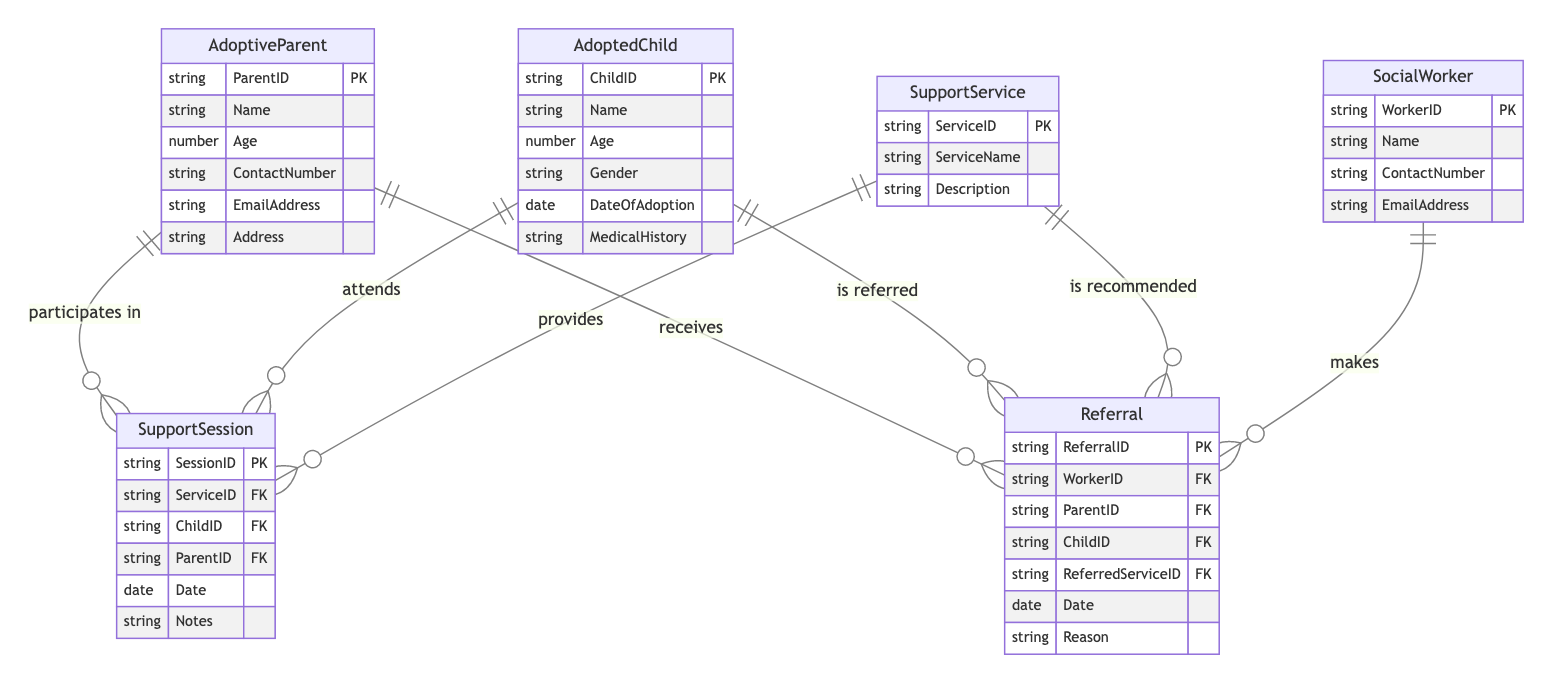What is the primary key of the AdoptiveParent entity? The primary key for the AdoptiveParent entity is ParentID, which uniquely identifies each adoptive parent in the database.
Answer: ParentID How many attributes does the SupportService entity have? The SupportService entity has three attributes: ServiceID, ServiceName, and Description.
Answer: 3 Which entity is involved in making a referral? The entity involved in making a referral is the SocialWorker, who has a relationship with the Referral entity as the one who creates it.
Answer: SocialWorker What relationship exists between AdoptiveParent and SupportSession? The relationship between AdoptiveParent and SupportSession is that the adoptive parent participates in the support session, indicating they are involved in the associated support activities.
Answer: participates in How many foreign keys are present in the Referral entity? The Referral entity has three foreign keys: WorkerID, ParentID, and ChildID, which link it to the SocialWorker, AdoptiveParent, and AdoptedChild entities respectively.
Answer: 3 What is the purpose of the ServiceID attribute in the SupportSession entity? The ServiceID attribute in the SupportSession entity serves as a foreign key to link the specific support session to the corresponding support service provided.
Answer: foreign key Which two entities are related through the Referral entity? The Referral entity relates the SocialWorker and the AdoptiveParent as well as the AdoptedChild, indicating that a social worker refers an adoptive parent and child to a service.
Answer: SocialWorker and AdoptiveParent, AdoptedChild What does the Notes attribute in SupportSession signify? The Notes attribute in the SupportSession is used to capture any additional information or observations related to the support session, providing context or specific details.
Answer: additional information How many entities are there in this diagram? There are six entities depicted in the diagram: AdoptiveParent, AdoptedChild, SupportService, SupportSession, SocialWorker, and Referral.
Answer: 6 